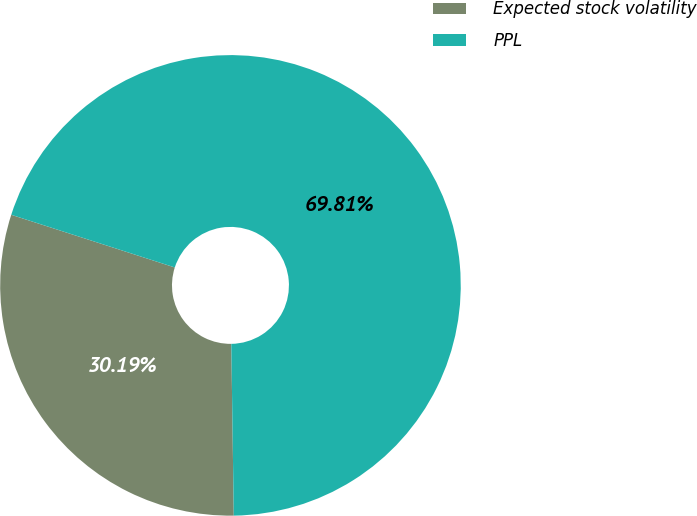Convert chart. <chart><loc_0><loc_0><loc_500><loc_500><pie_chart><fcel>Expected stock volatility<fcel>PPL<nl><fcel>30.19%<fcel>69.81%<nl></chart> 